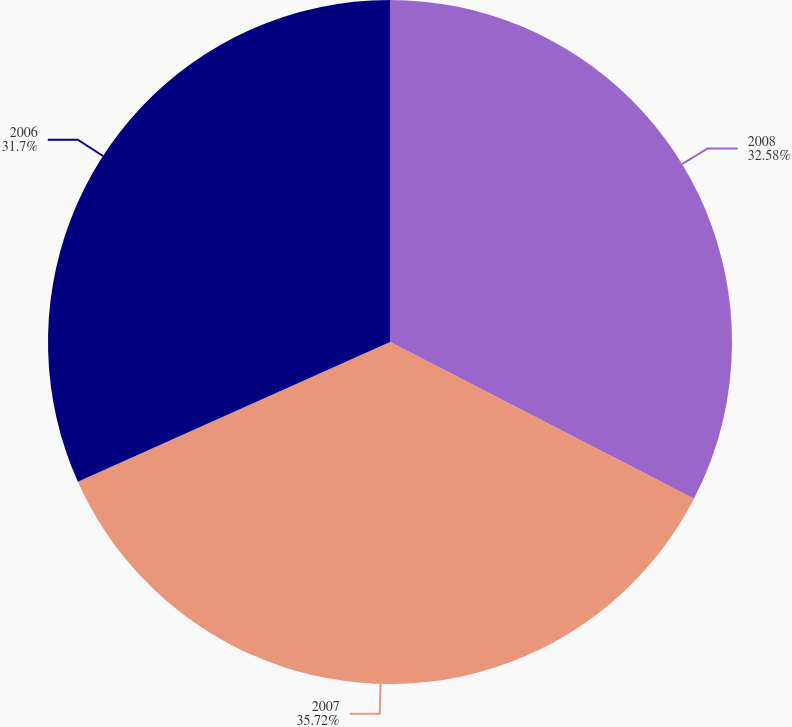Convert chart to OTSL. <chart><loc_0><loc_0><loc_500><loc_500><pie_chart><fcel>2008<fcel>2007<fcel>2006<nl><fcel>32.58%<fcel>35.72%<fcel>31.7%<nl></chart> 